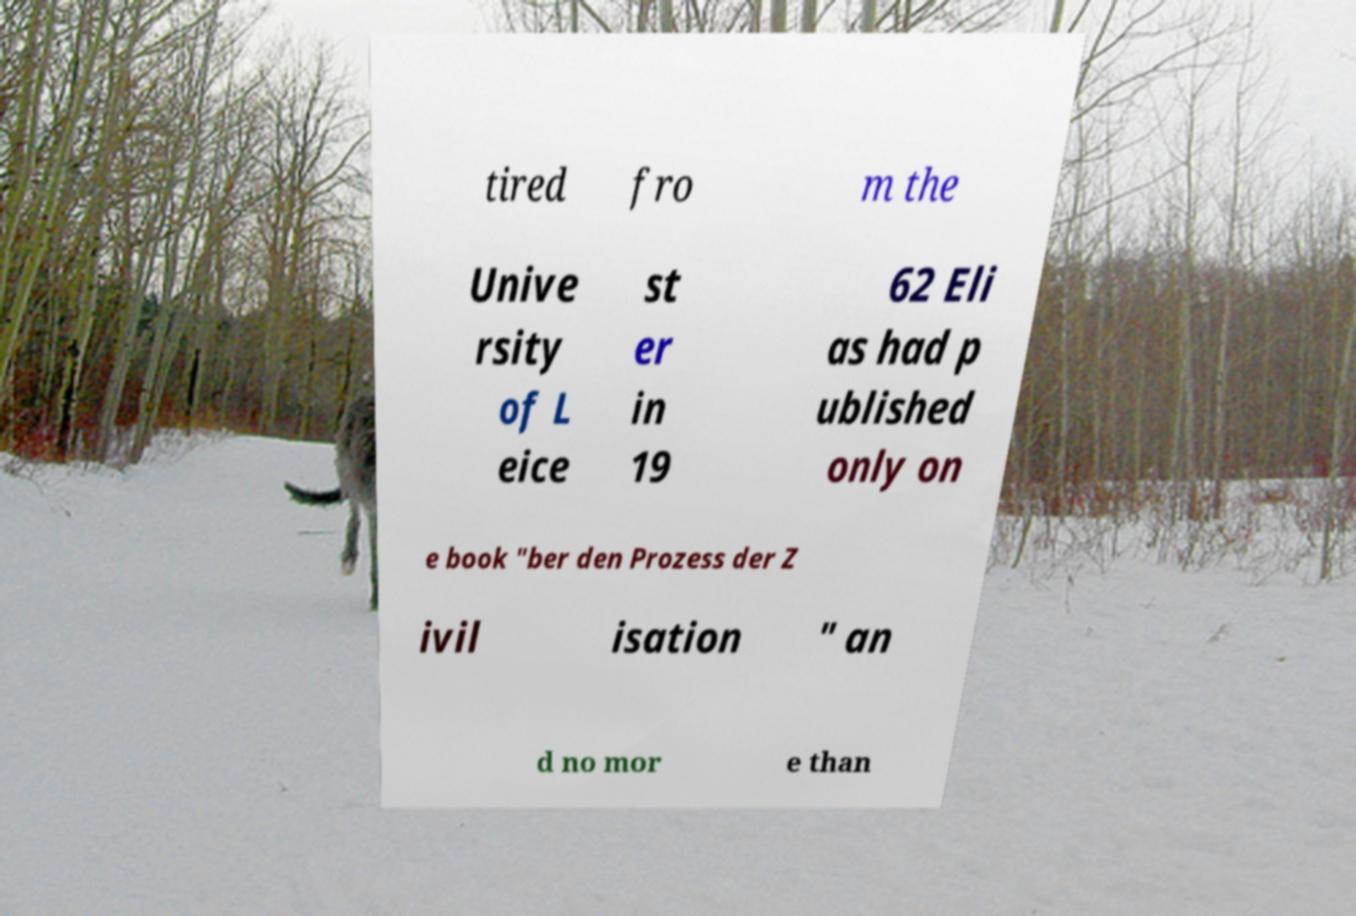Can you read and provide the text displayed in the image?This photo seems to have some interesting text. Can you extract and type it out for me? tired fro m the Unive rsity of L eice st er in 19 62 Eli as had p ublished only on e book "ber den Prozess der Z ivil isation " an d no mor e than 